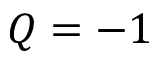Convert formula to latex. <formula><loc_0><loc_0><loc_500><loc_500>Q = - 1</formula> 